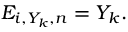Convert formula to latex. <formula><loc_0><loc_0><loc_500><loc_500>E _ { i , Y _ { k } , n } = Y _ { k } .</formula> 